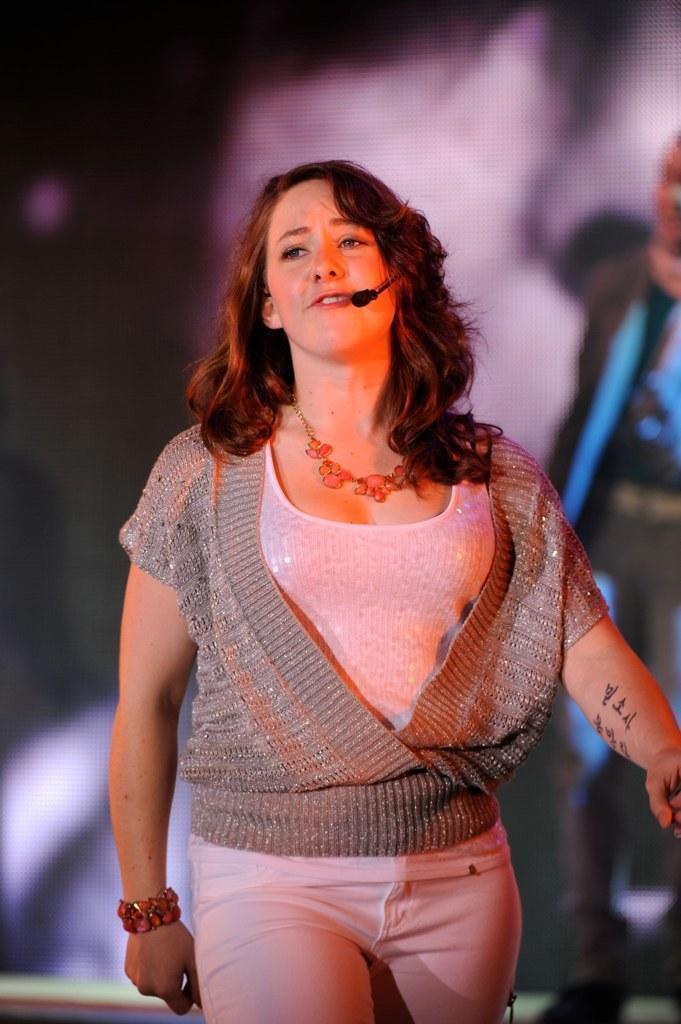How would you summarize this image in a sentence or two? In the foreground of the picture we can see a beautiful woman singing, she might be walking. The background is blurred. 